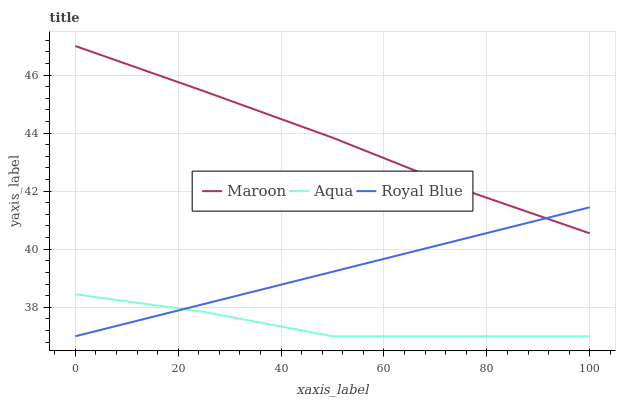Does Maroon have the minimum area under the curve?
Answer yes or no. No. Does Aqua have the maximum area under the curve?
Answer yes or no. No. Is Maroon the smoothest?
Answer yes or no. No. Is Maroon the roughest?
Answer yes or no. No. Does Maroon have the lowest value?
Answer yes or no. No. Does Aqua have the highest value?
Answer yes or no. No. Is Aqua less than Maroon?
Answer yes or no. Yes. Is Maroon greater than Aqua?
Answer yes or no. Yes. Does Aqua intersect Maroon?
Answer yes or no. No. 